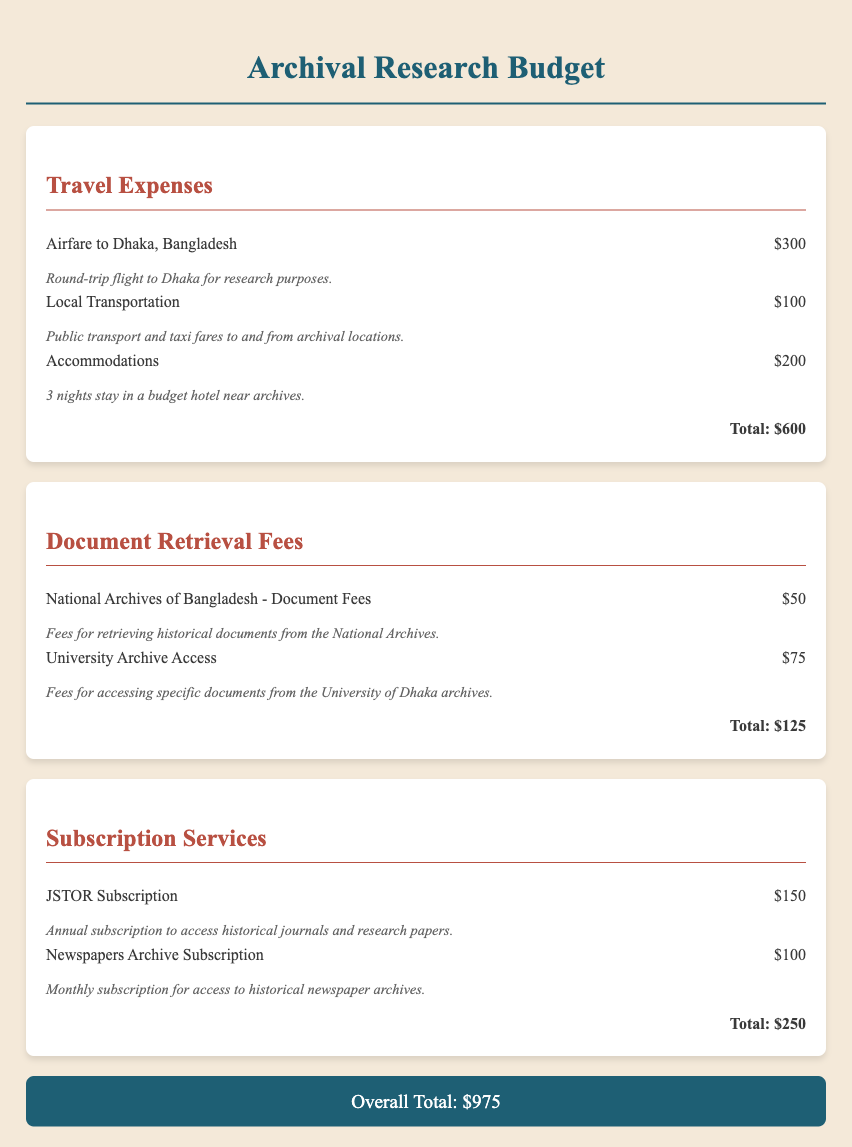What is the total travel expense? The total travel expense is calculated by summing the individual travel costs, which are $300 for airfare, $100 for local transportation, and $200 for accommodations, resulting in $600.
Answer: $600 What is the document retrieval fee for the National Archives of Bangladesh? The document retrieval fee for the National Archives of Bangladesh is stated directly in the document as $50.
Answer: $50 What is the annual subscription cost for JSTOR? The document specifies the annual subscription cost for JSTOR as $150.
Answer: $150 What is the overall total budget for archival research? The overall total budget for archival research is the sum of all expenses detailed in the document, which amounts to $975.
Answer: $975 How many nights will accommodations be used? The document states that accommodations for the research trip will cover 3 nights.
Answer: 3 nights What type of service is the Newspapers Archive Subscription? The Newspapers Archive Subscription is categorized under subscription services in the budget document.
Answer: Subscription service What is the cost of accessing documents from the University Archive? The cost of accessing documents from the University Archive is listed as $75 in the budget.
Answer: $75 What is the total for document retrieval fees? The total for document retrieval fees combines $50 for the National Archives and $75 for the University Archive, resulting in $125.
Answer: $125 